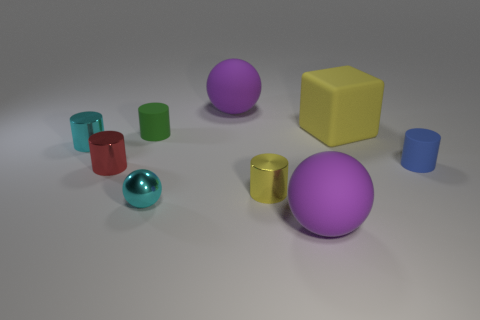Add 1 green objects. How many objects exist? 10 Subtract all tiny metal cylinders. How many cylinders are left? 2 Subtract all gray blocks. How many purple spheres are left? 2 Subtract all yellow cylinders. How many cylinders are left? 4 Subtract 2 cylinders. How many cylinders are left? 3 Subtract all cylinders. How many objects are left? 4 Subtract all gray spheres. Subtract all cyan cubes. How many spheres are left? 3 Subtract 0 blue spheres. How many objects are left? 9 Subtract all cyan cylinders. Subtract all red objects. How many objects are left? 7 Add 3 metallic spheres. How many metallic spheres are left? 4 